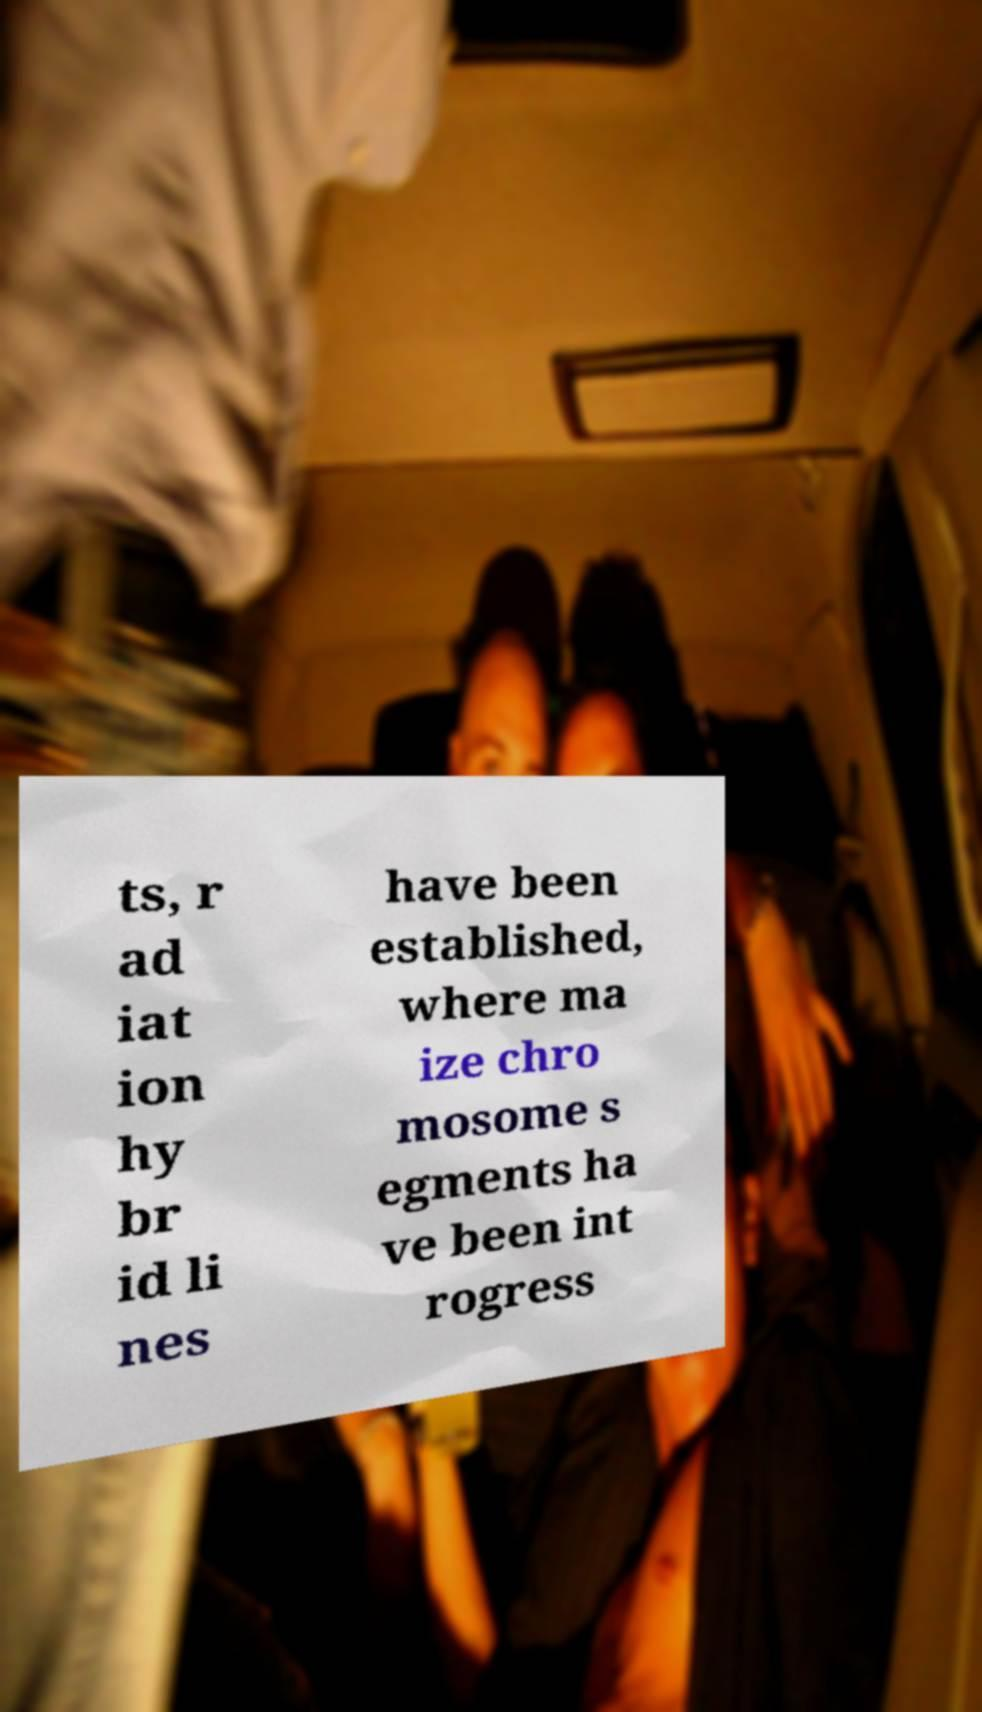There's text embedded in this image that I need extracted. Can you transcribe it verbatim? ts, r ad iat ion hy br id li nes have been established, where ma ize chro mosome s egments ha ve been int rogress 